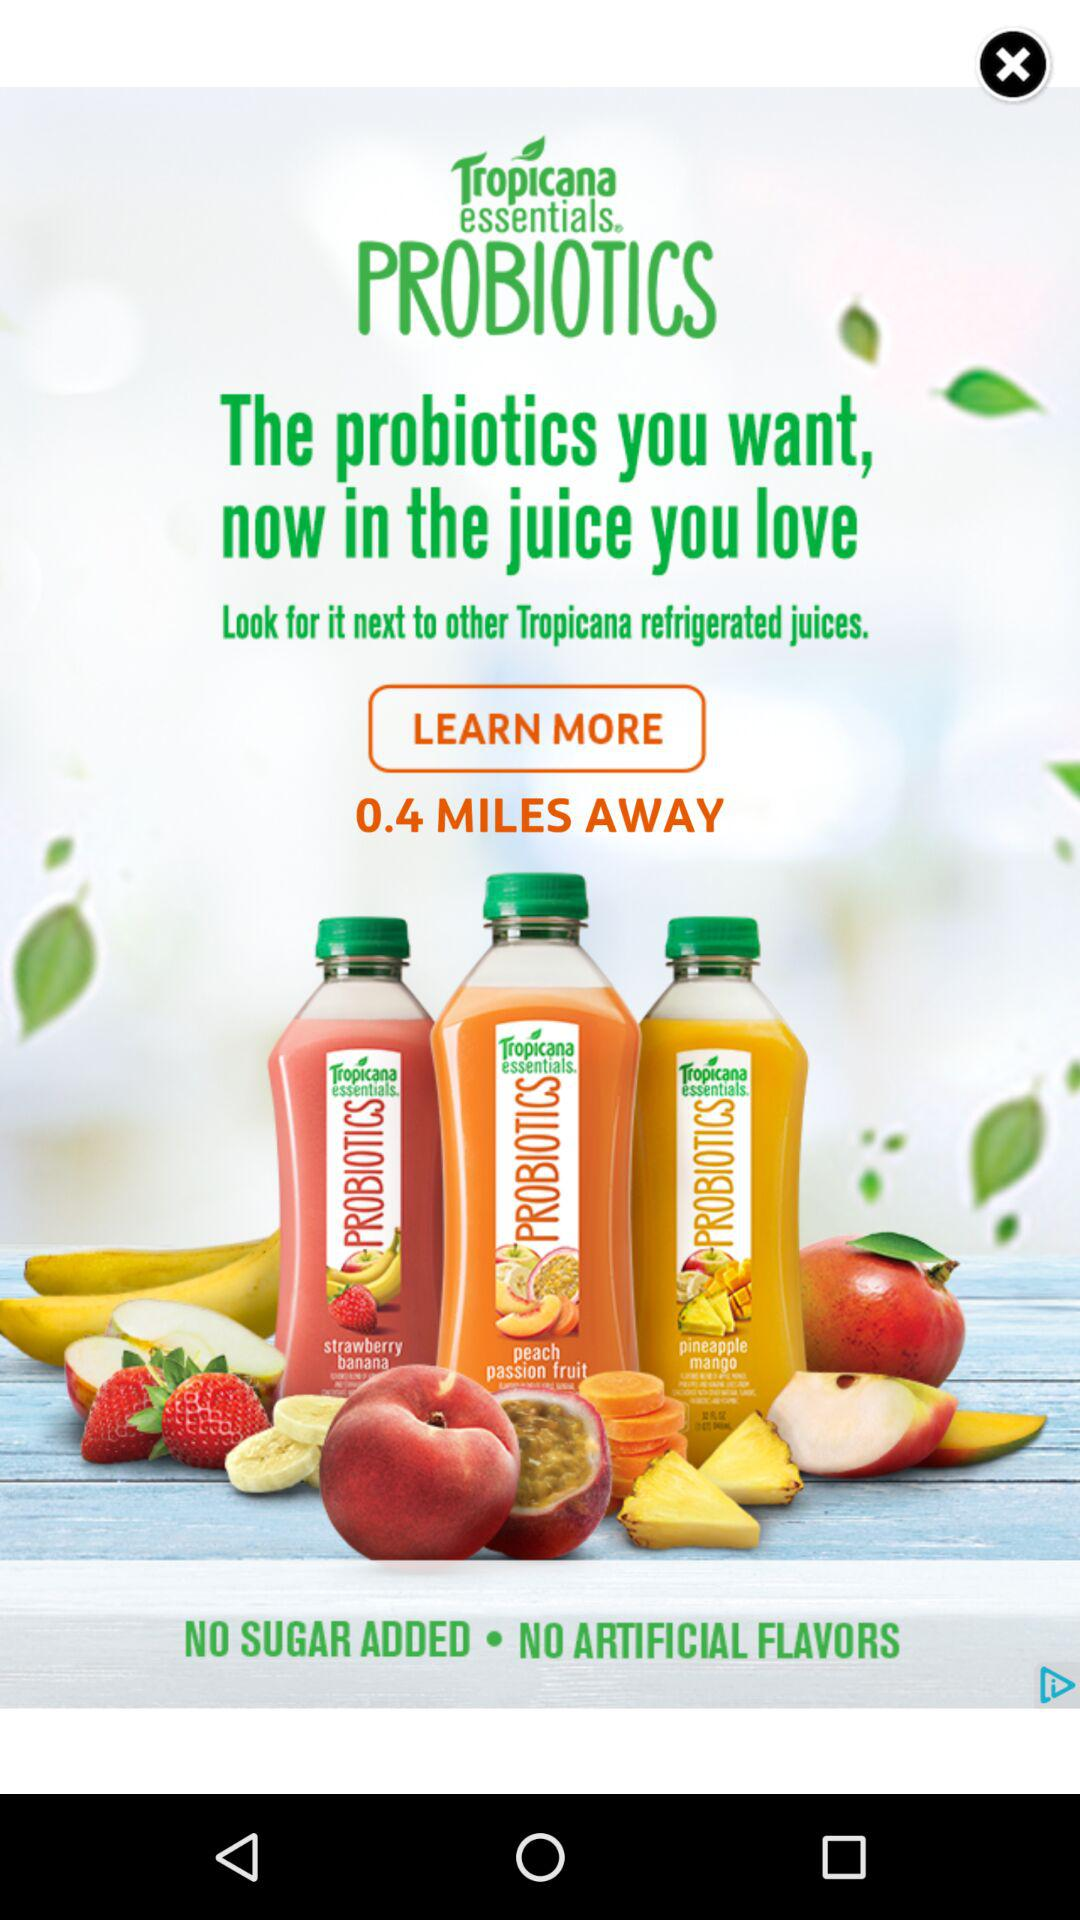How many miles away is the store?
Answer the question using a single word or phrase. 0.4 